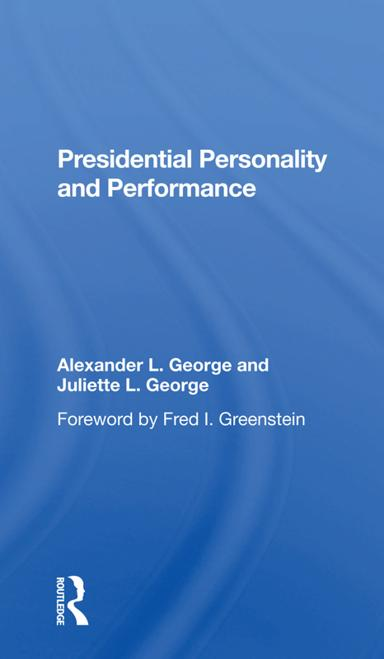Who are the authors of the book mentioned in the image? The book, as displayed in the image, is authored by Alexander L. George and Juliette L. George. This duo has contributed significantly to the literature on presidential personality and its impact on governance. 